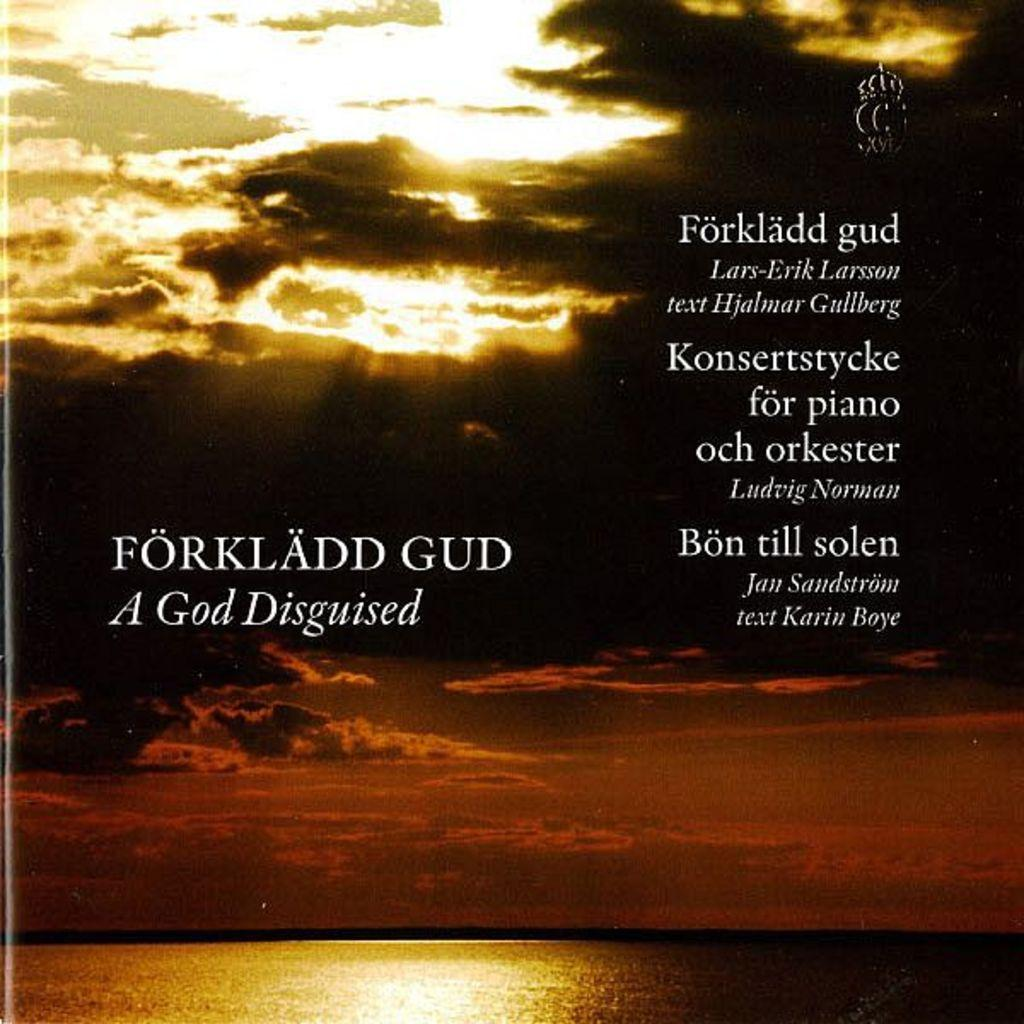<image>
Summarize the visual content of the image. the name God is next to a sky with clouds 